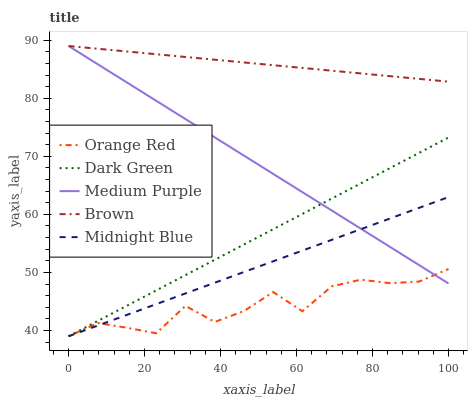Does Orange Red have the minimum area under the curve?
Answer yes or no. Yes. Does Brown have the maximum area under the curve?
Answer yes or no. Yes. Does Midnight Blue have the minimum area under the curve?
Answer yes or no. No. Does Midnight Blue have the maximum area under the curve?
Answer yes or no. No. Is Dark Green the smoothest?
Answer yes or no. Yes. Is Orange Red the roughest?
Answer yes or no. Yes. Is Brown the smoothest?
Answer yes or no. No. Is Brown the roughest?
Answer yes or no. No. Does Midnight Blue have the lowest value?
Answer yes or no. Yes. Does Brown have the lowest value?
Answer yes or no. No. Does Brown have the highest value?
Answer yes or no. Yes. Does Midnight Blue have the highest value?
Answer yes or no. No. Is Orange Red less than Brown?
Answer yes or no. Yes. Is Brown greater than Midnight Blue?
Answer yes or no. Yes. Does Midnight Blue intersect Dark Green?
Answer yes or no. Yes. Is Midnight Blue less than Dark Green?
Answer yes or no. No. Is Midnight Blue greater than Dark Green?
Answer yes or no. No. Does Orange Red intersect Brown?
Answer yes or no. No. 